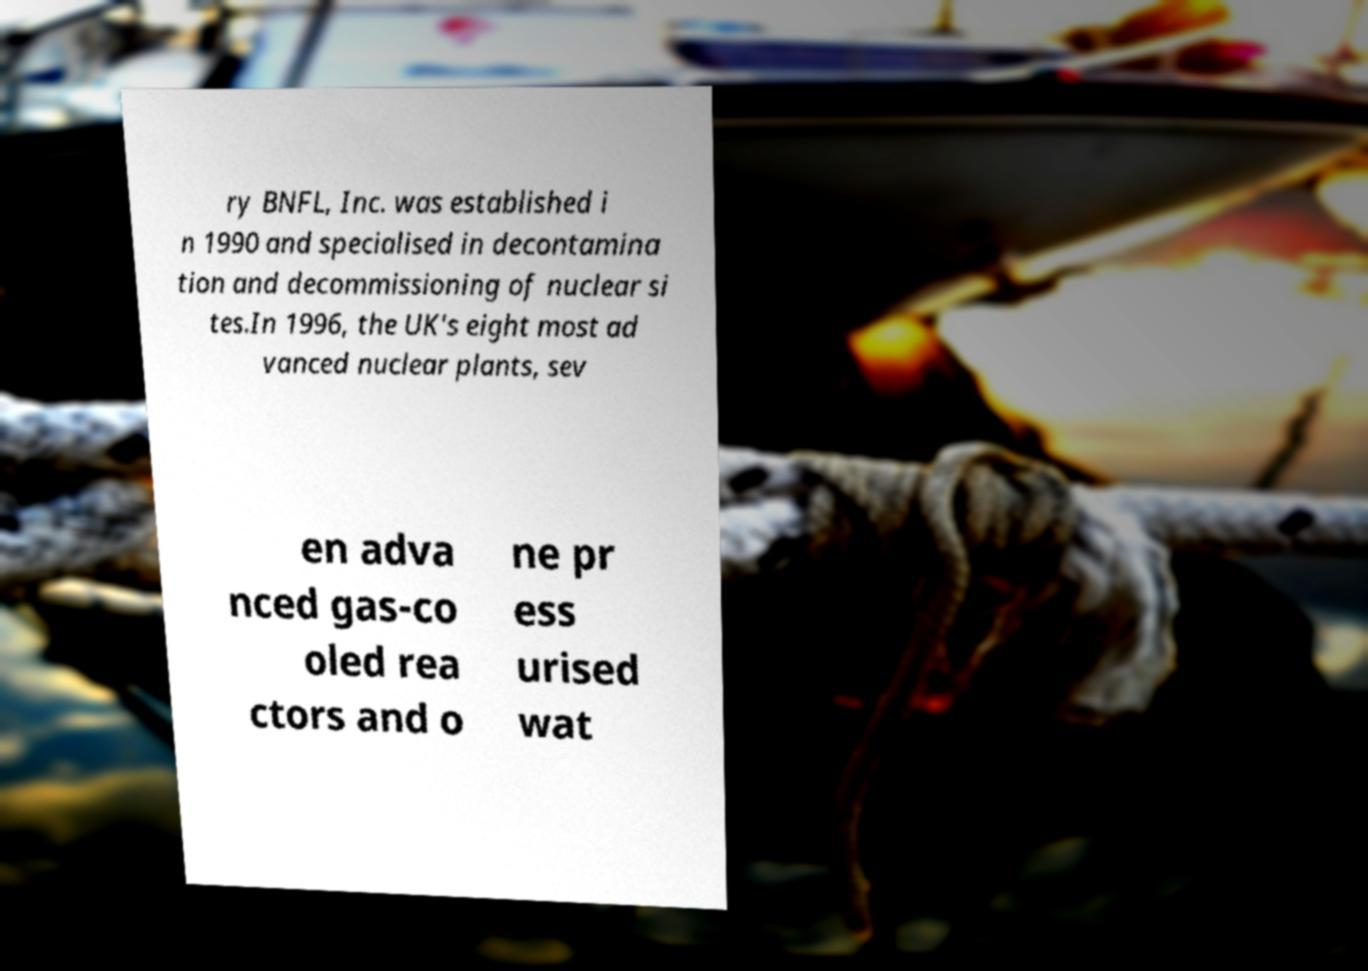What messages or text are displayed in this image? I need them in a readable, typed format. ry BNFL, Inc. was established i n 1990 and specialised in decontamina tion and decommissioning of nuclear si tes.In 1996, the UK's eight most ad vanced nuclear plants, sev en adva nced gas-co oled rea ctors and o ne pr ess urised wat 